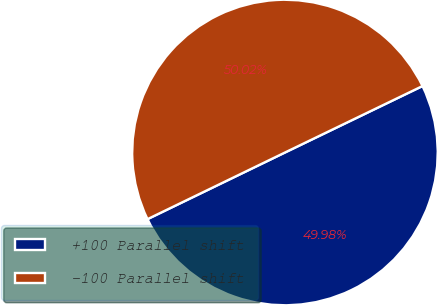Convert chart to OTSL. <chart><loc_0><loc_0><loc_500><loc_500><pie_chart><fcel>+100 Parallel shift<fcel>-100 Parallel shift<nl><fcel>49.98%<fcel>50.02%<nl></chart> 